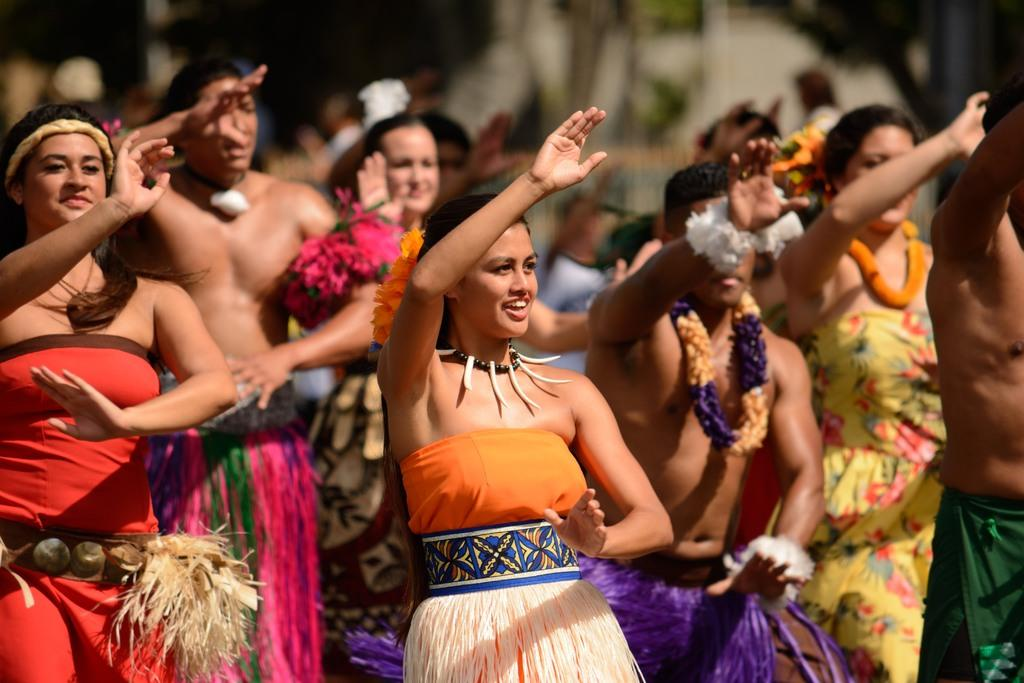How many people are in the image? The number of people in the image is not specified, but there are people present. What is the position of the people in the image? The people are standing on the ground. What are the people wearing in the image? The people are wearing costumes. Are there any additional accessories being worn by some people in the image? Yes, some people are wearing garlands around their necks. What type of hat is the police officer wearing in the image? There is no police officer or hat present in the image. What is the zinc content of the costumes being worn by the people in the image? The zinc content of the costumes cannot be determined from the image, as it does not provide information about the materials used in the costumes. 